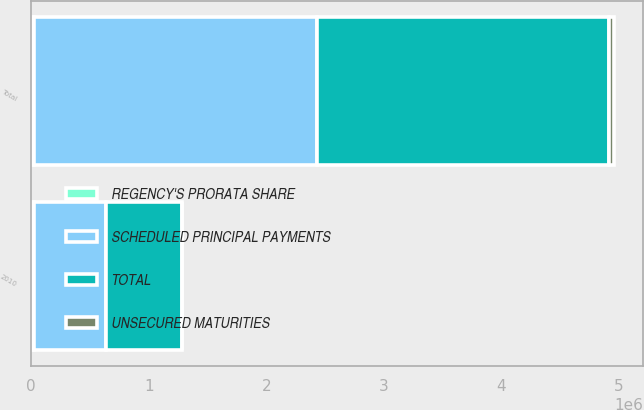Convert chart. <chart><loc_0><loc_0><loc_500><loc_500><stacked_bar_chart><ecel><fcel>2010<fcel>Total<nl><fcel>UNSECURED MATURITIES<fcel>3642<fcel>45610<nl><fcel>SCHEDULED PRINCIPAL PAYMENTS<fcel>613310<fcel>2.40546e+06<nl><fcel>REGENCY'S PRORATA SHARE<fcel>26858<fcel>26858<nl><fcel>TOTAL<fcel>643810<fcel>2.47793e+06<nl></chart> 